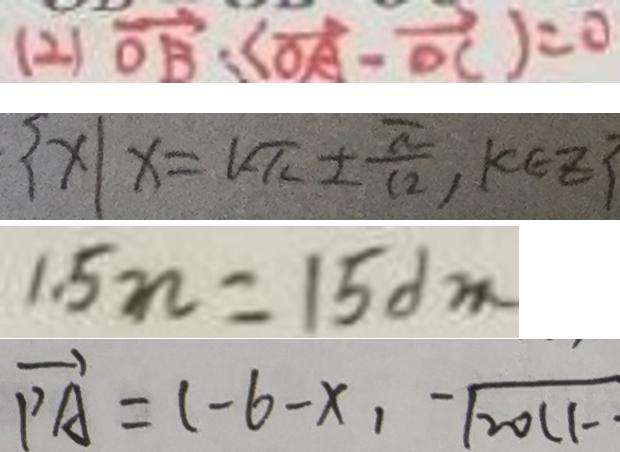<formula> <loc_0><loc_0><loc_500><loc_500>( 2 ) \overrightarrow { O B } : ( \overrightarrow { O A } - \overrightarrow { O C } ) = 0 
 \{ x \vert x = l \pi \pm \frac { \pi } { 1 2 } , k \pi z \} 
 1 . 5 n = 1 5 d m 
 \overrightarrow { P A } = ( - 6 - x , - \sqrt { 2 0 1 1 - }</formula> 